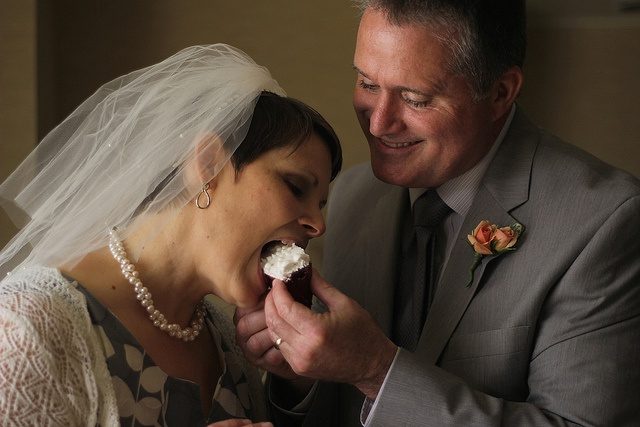Describe the objects in this image and their specific colors. I can see people in black, gray, and maroon tones, people in black, darkgray, and gray tones, tie in black, gray, and maroon tones, and cake in black, lightgray, and tan tones in this image. 